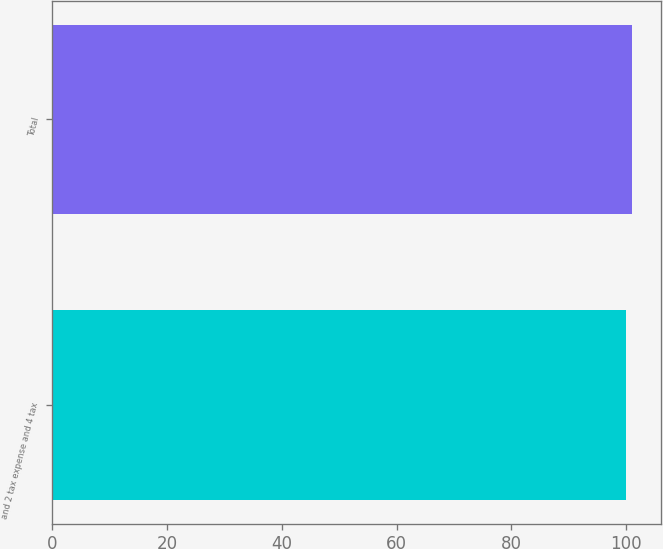Convert chart to OTSL. <chart><loc_0><loc_0><loc_500><loc_500><bar_chart><fcel>and 2 tax expense and 4 tax<fcel>Total<nl><fcel>100<fcel>101<nl></chart> 